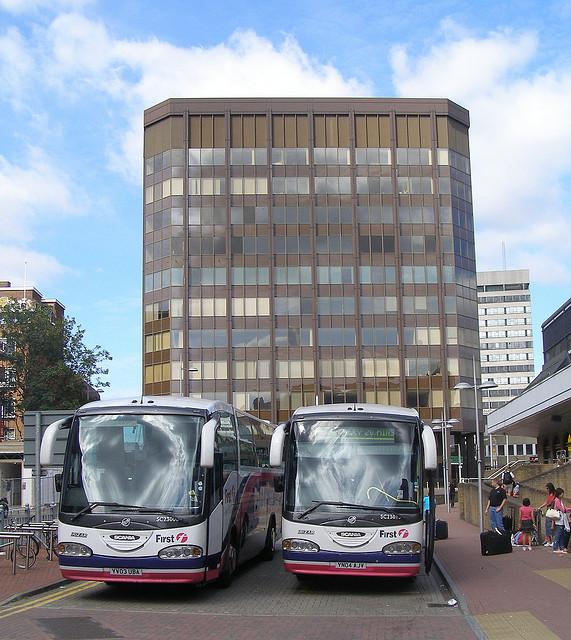What is the black bag on the sidewalk?

Choices:
A) tools
B) luggage
C) furniture
D) groceries luggage 